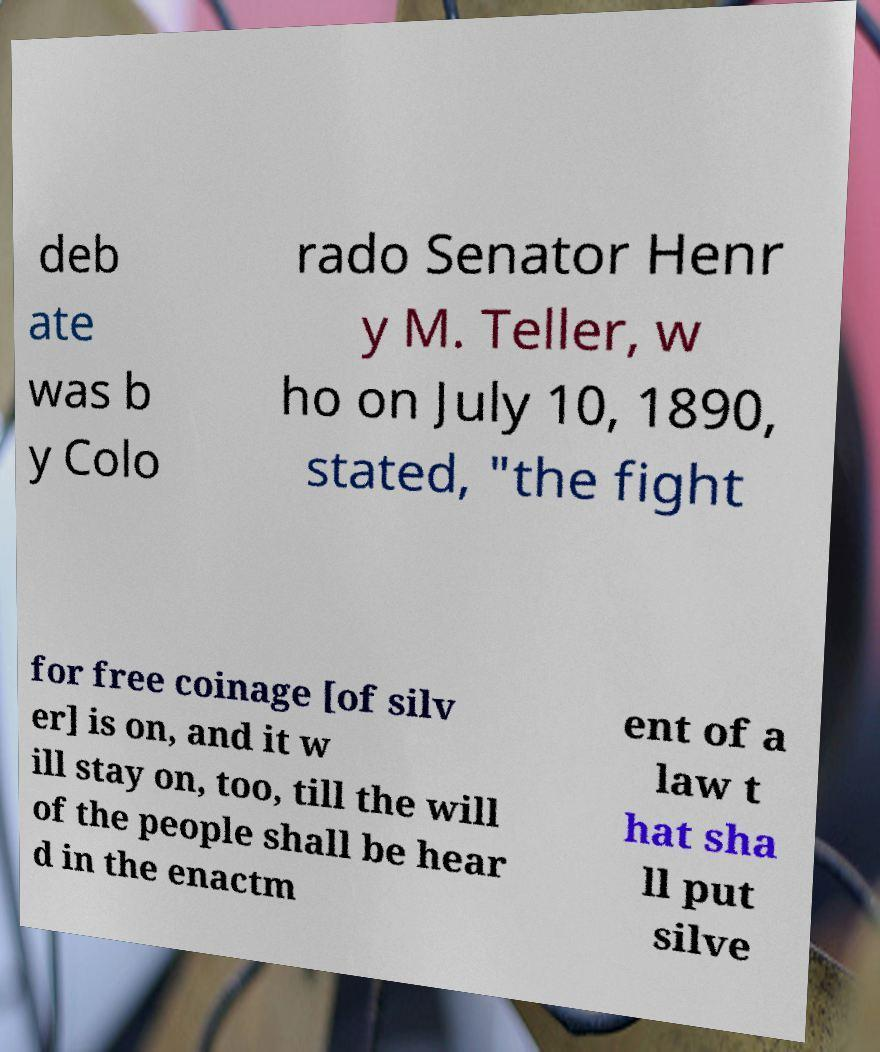There's text embedded in this image that I need extracted. Can you transcribe it verbatim? deb ate was b y Colo rado Senator Henr y M. Teller, w ho on July 10, 1890, stated, "the fight for free coinage [of silv er] is on, and it w ill stay on, too, till the will of the people shall be hear d in the enactm ent of a law t hat sha ll put silve 